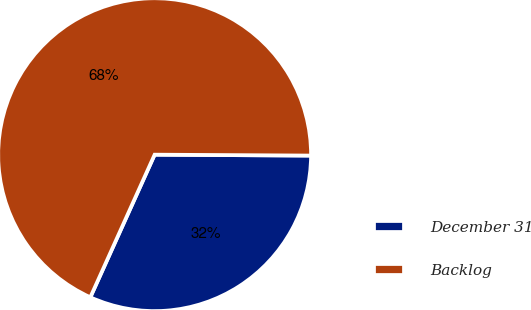<chart> <loc_0><loc_0><loc_500><loc_500><pie_chart><fcel>December 31<fcel>Backlog<nl><fcel>31.65%<fcel>68.35%<nl></chart> 